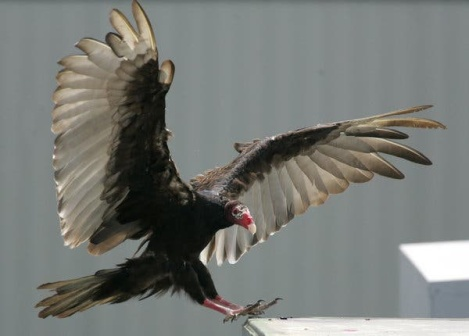How does this image speak to the interaction between nature and human architecture? This image beautifully illustrates the delicate balance between nature and human architecture. The vulture, a symbol of the wild, maintains its age-old behaviors even in the proximity of man-made structures. The gray building with its stark lines contrasts with the organic form of the vulture, yet both coexist in the sharegpt4v/same frame. It speaks to an intersection where human development meets nature’s persistence, reminding us of the ongoing dialogue between our constructed environments and the natural world. This overlays a harmonious coexistence where both entities adapt and share the landscape. 